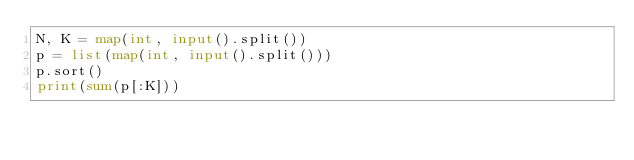<code> <loc_0><loc_0><loc_500><loc_500><_Python_>N, K = map(int, input().split())
p = list(map(int, input().split()))
p.sort()
print(sum(p[:K]))</code> 